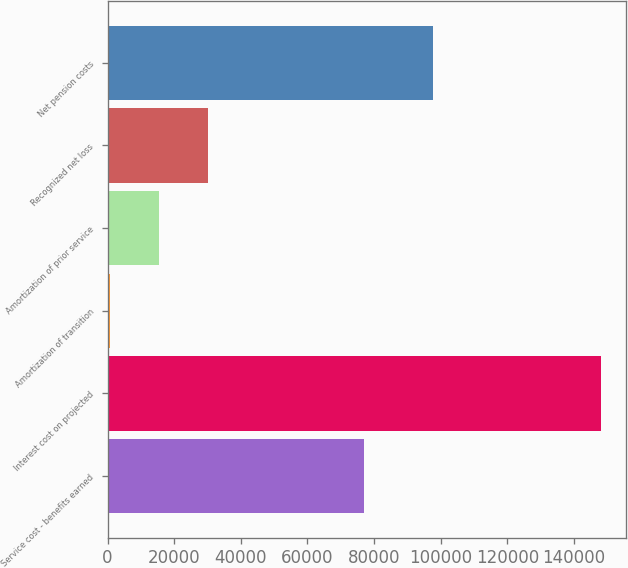Convert chart. <chart><loc_0><loc_0><loc_500><loc_500><bar_chart><fcel>Service cost - benefits earned<fcel>Interest cost on projected<fcel>Amortization of transition<fcel>Amortization of prior service<fcel>Recognized net loss<fcel>Net pension costs<nl><fcel>76946<fcel>148092<fcel>763<fcel>15495.9<fcel>30228.8<fcel>97521<nl></chart> 